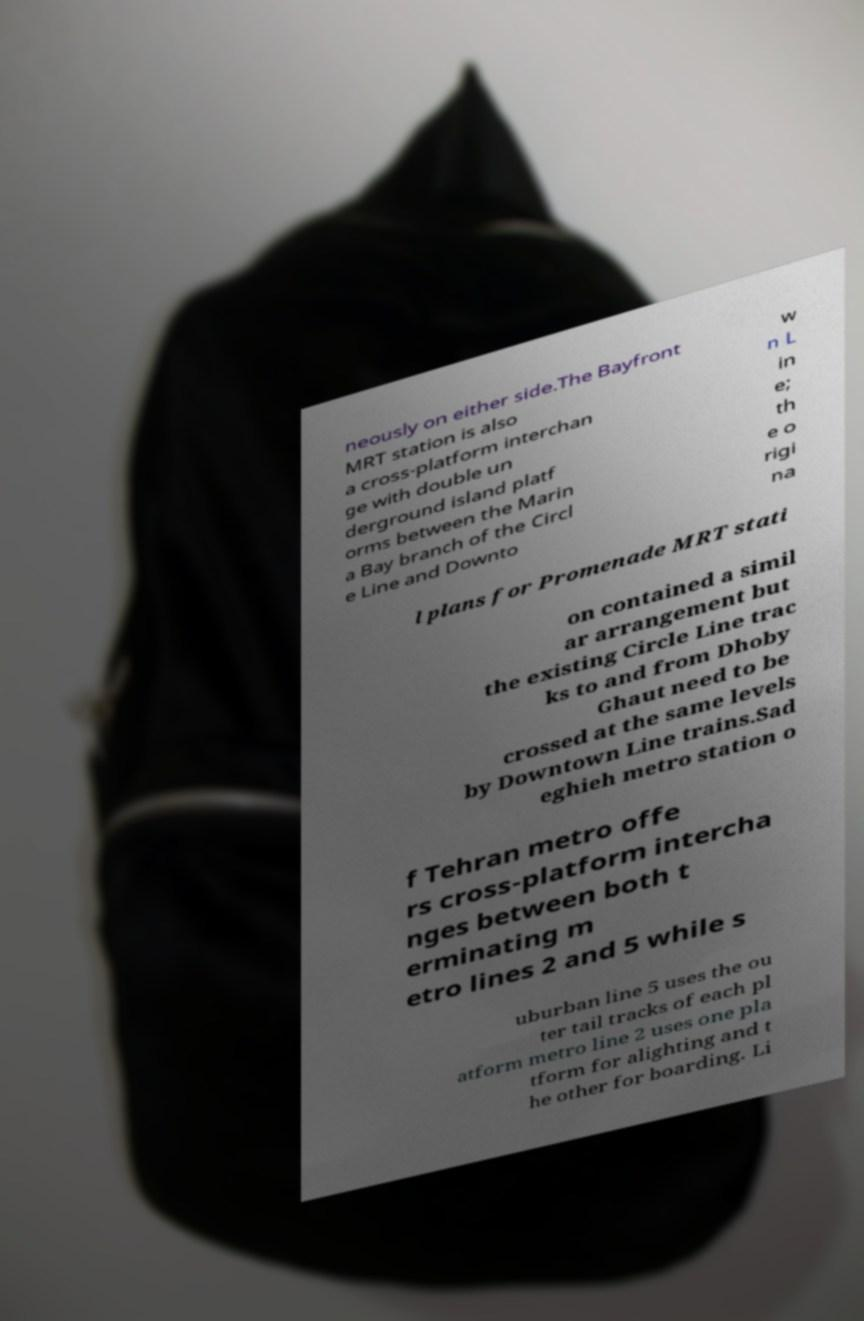Can you accurately transcribe the text from the provided image for me? neously on either side.The Bayfront MRT station is also a cross-platform interchan ge with double un derground island platf orms between the Marin a Bay branch of the Circl e Line and Downto w n L in e; th e o rigi na l plans for Promenade MRT stati on contained a simil ar arrangement but the existing Circle Line trac ks to and from Dhoby Ghaut need to be crossed at the same levels by Downtown Line trains.Sad eghieh metro station o f Tehran metro offe rs cross-platform intercha nges between both t erminating m etro lines 2 and 5 while s uburban line 5 uses the ou ter tail tracks of each pl atform metro line 2 uses one pla tform for alighting and t he other for boarding. Li 